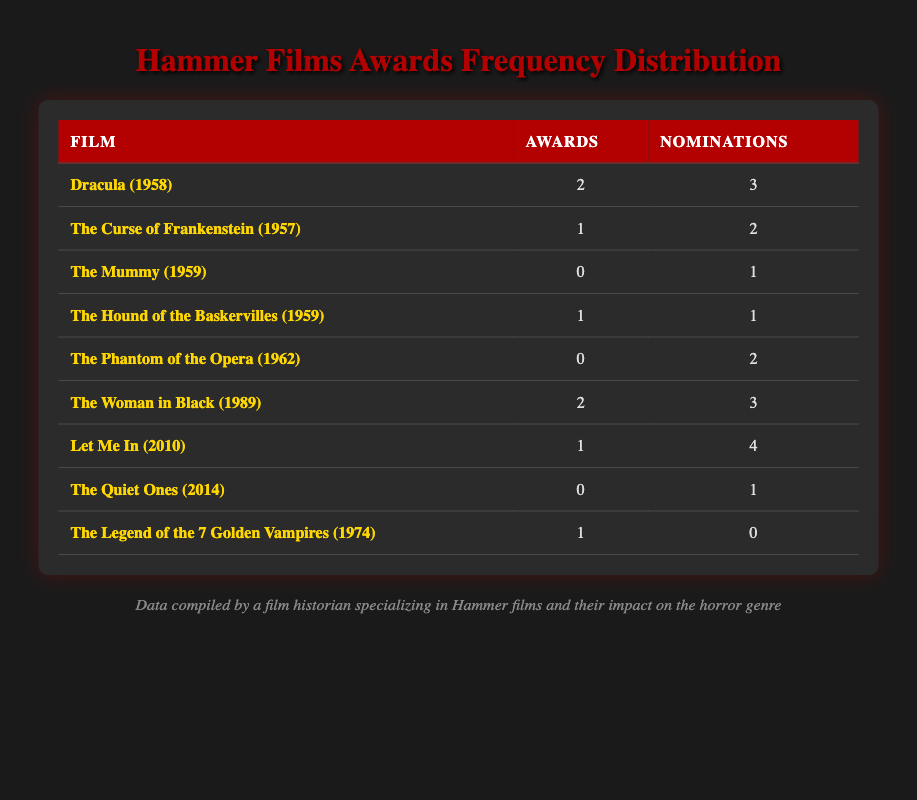What is the total number of awards won by Hammer films from the table? By reviewing the "Awards" column, we find the total awards won by adding all the values: 2 (Dracula) + 1 (The Curse of Frankenstein) + 0 (The Mummy) + 1 (The Hound of the Baskervilles) + 0 (The Phantom of the Opera) + 2 (The Woman in Black) + 1 (Let Me In) + 0 (The Quiet Ones) + 1 (The Legend of the 7 Golden Vampires) = 8 awards
Answer: 8 How many Hammer films received no awards? From the "Awards" column, we identify the films that have 0 awards. The films are: The Mummy, The Phantom of the Opera, and The Quiet Ones. Counting these gives a total of 3 films with no awards.
Answer: 3 What film had the most nominations? Looking at the "Nominations" column, we compare the values, and we see that Let Me In has 4 nominations, which is the highest.
Answer: Let Me In Is it true that both Dracula and The Woman in Black won the same number of awards? Checking the "Awards" column, Dracula has 2 awards and The Woman in Black also has 2 awards. Since they are equal, the statement is true.
Answer: Yes What is the average number of nominations for Hammer films? First, we sum the nominations: 3 (Dracula) + 2 (The Curse of Frankenstein) + 1 (The Mummy) + 1 (The Hound of the Baskervilles) + 2 (The Phantom of the Opera) + 3 (The Woman in Black) + 4 (Let Me In) + 1 (The Quiet Ones) + 0 (The Legend of the 7 Golden Vampires) = 17. There are 9 films, so the average is 17 divided by 9, which equals approximately 1.89.
Answer: 1.89 